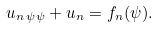Convert formula to latex. <formula><loc_0><loc_0><loc_500><loc_500>u _ { n \, \psi \psi } + u _ { n } = f _ { n } ( \psi ) .</formula> 